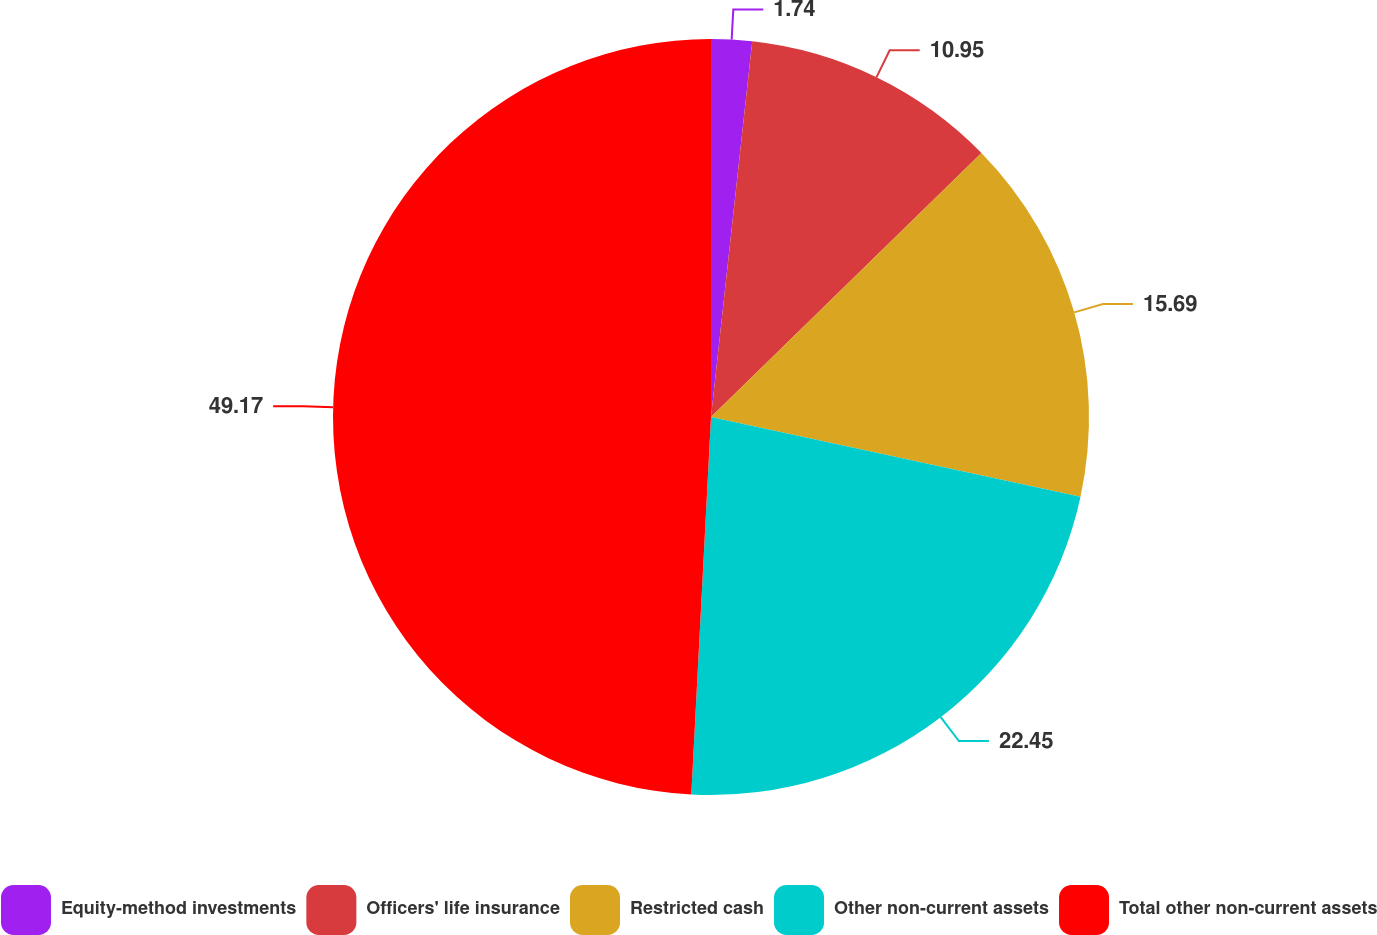Convert chart. <chart><loc_0><loc_0><loc_500><loc_500><pie_chart><fcel>Equity-method investments<fcel>Officers' life insurance<fcel>Restricted cash<fcel>Other non-current assets<fcel>Total other non-current assets<nl><fcel>1.74%<fcel>10.95%<fcel>15.69%<fcel>22.45%<fcel>49.17%<nl></chart> 